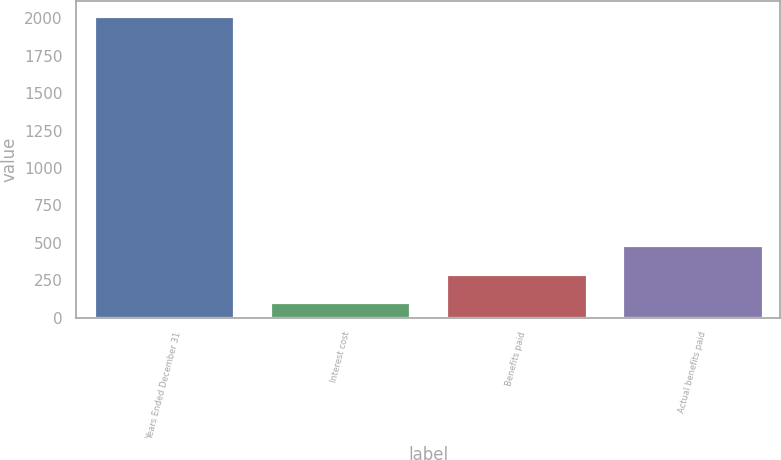Convert chart. <chart><loc_0><loc_0><loc_500><loc_500><bar_chart><fcel>Years Ended December 31<fcel>Interest cost<fcel>Benefits paid<fcel>Actual benefits paid<nl><fcel>2015<fcel>102<fcel>293.3<fcel>484.6<nl></chart> 